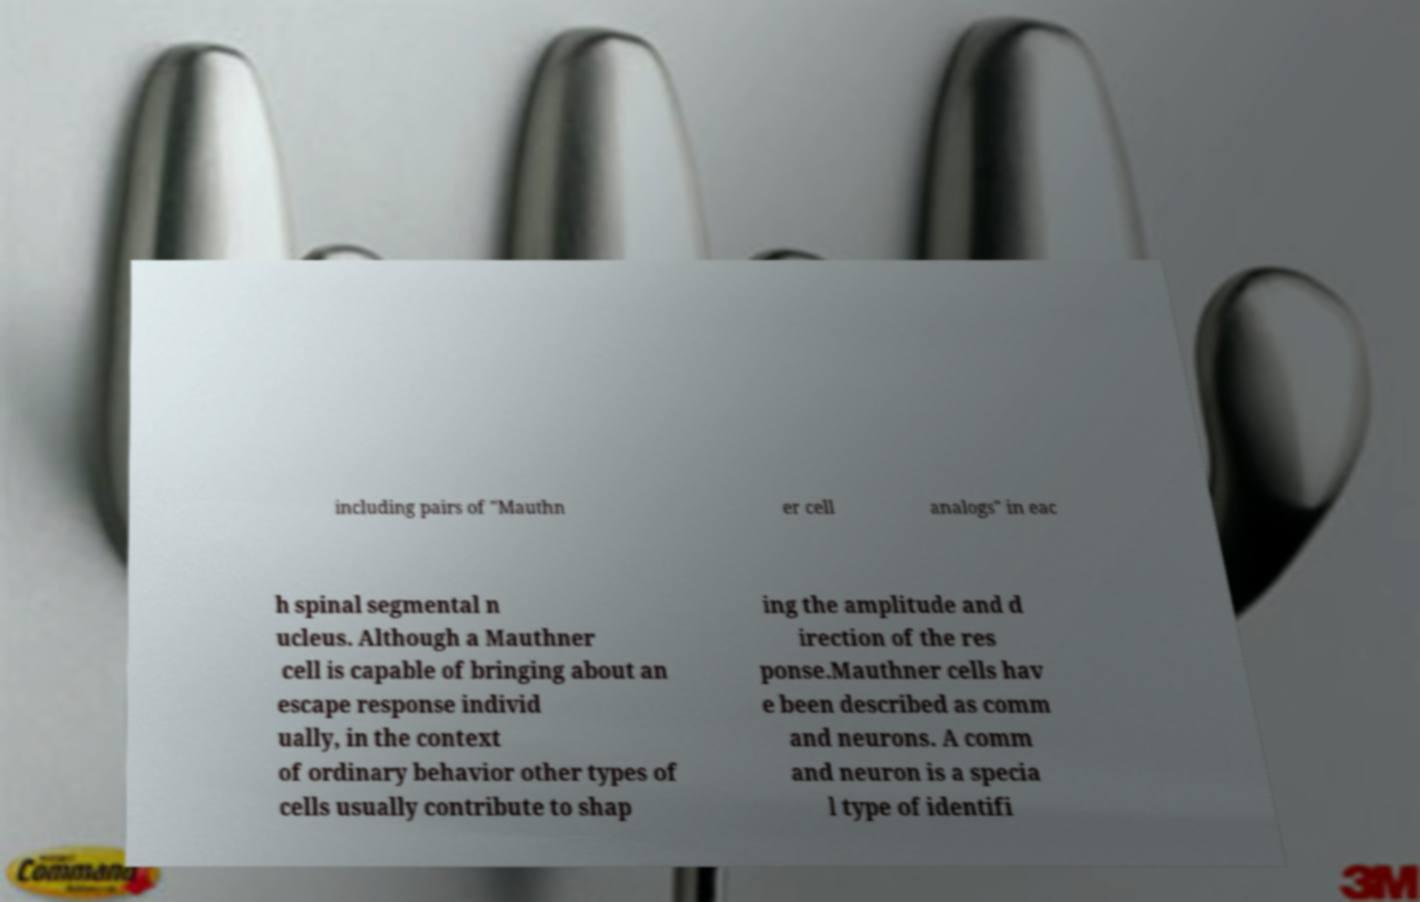I need the written content from this picture converted into text. Can you do that? including pairs of "Mauthn er cell analogs" in eac h spinal segmental n ucleus. Although a Mauthner cell is capable of bringing about an escape response individ ually, in the context of ordinary behavior other types of cells usually contribute to shap ing the amplitude and d irection of the res ponse.Mauthner cells hav e been described as comm and neurons. A comm and neuron is a specia l type of identifi 